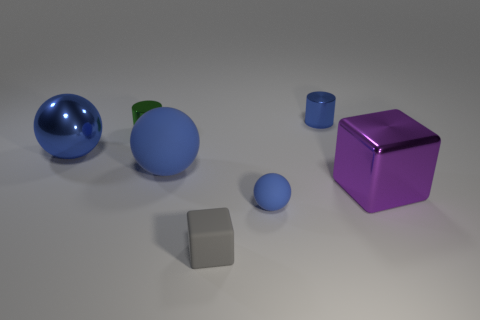There is a small cylinder that is the same color as the big metallic ball; what is it made of?
Provide a succinct answer. Metal. Is the green cylinder made of the same material as the large cube?
Your answer should be compact. Yes. How many other things are the same color as the big metal cube?
Your answer should be very brief. 0. Are there more rubber spheres than small rubber cylinders?
Offer a terse response. Yes. There is a gray rubber thing; does it have the same size as the blue metallic object that is to the right of the gray cube?
Ensure brevity in your answer.  Yes. What is the color of the small metallic thing that is right of the small rubber block?
Offer a terse response. Blue. What number of yellow things are small rubber cubes or spheres?
Your answer should be very brief. 0. What is the color of the metal block?
Your response must be concise. Purple. Are there any other things that have the same material as the green cylinder?
Your answer should be compact. Yes. Are there fewer big blue matte balls behind the large blue shiny object than purple cubes that are behind the large rubber ball?
Your response must be concise. No. 